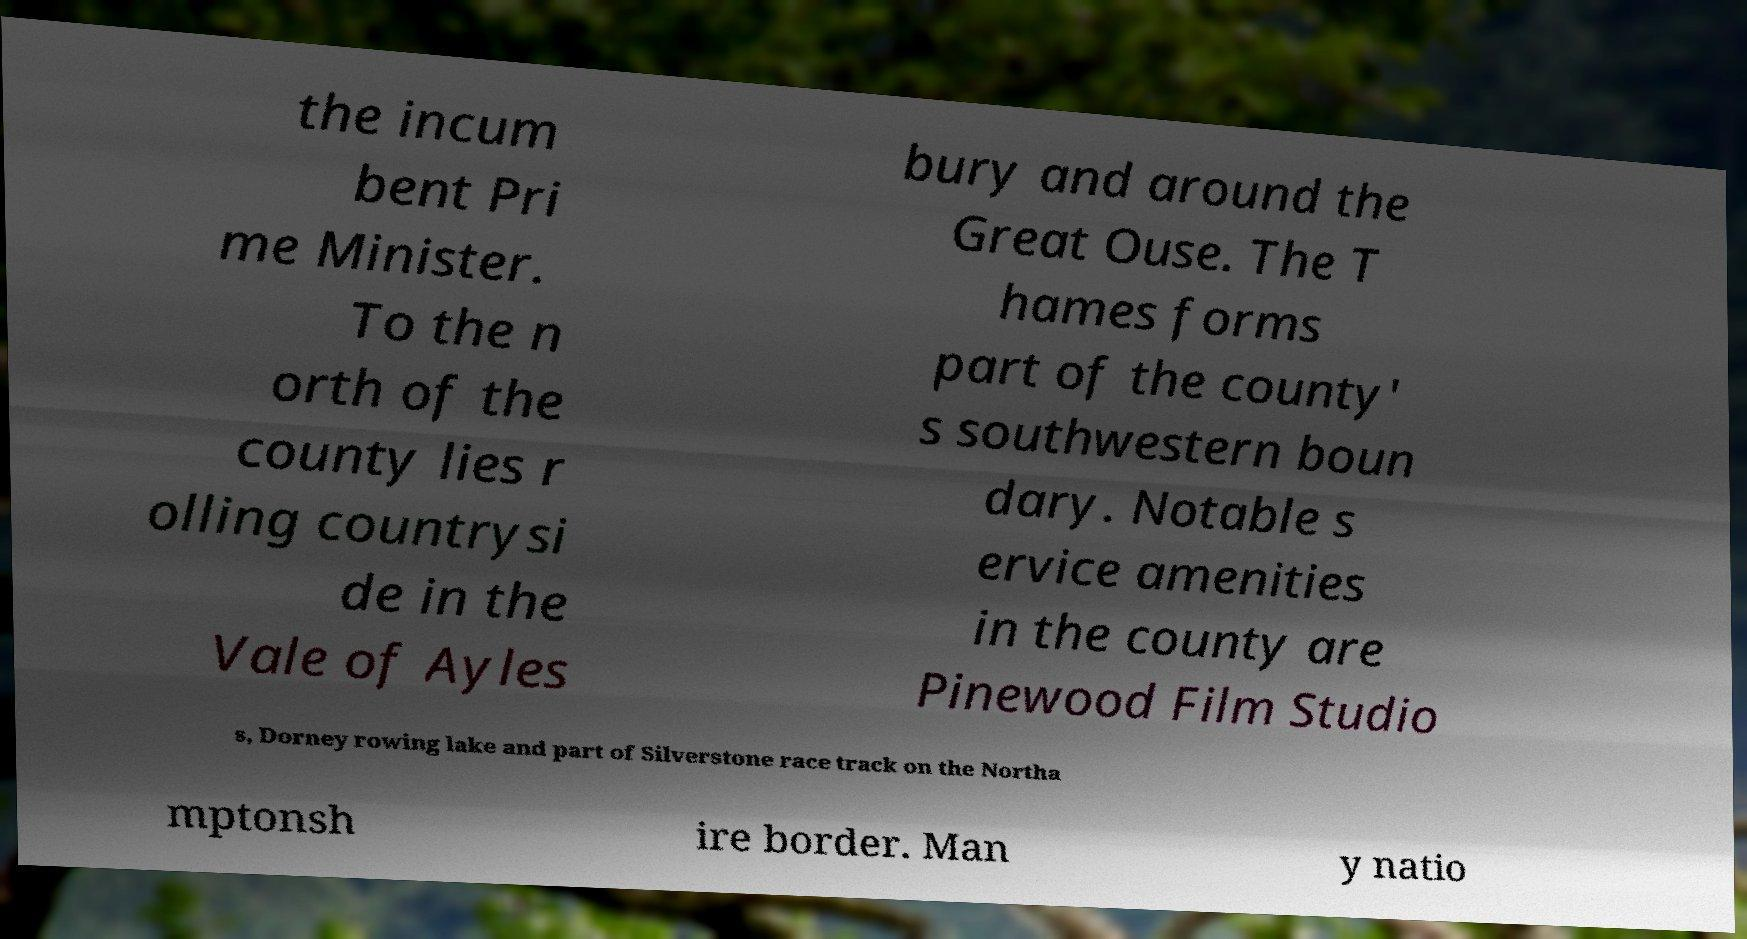For documentation purposes, I need the text within this image transcribed. Could you provide that? the incum bent Pri me Minister. To the n orth of the county lies r olling countrysi de in the Vale of Ayles bury and around the Great Ouse. The T hames forms part of the county' s southwestern boun dary. Notable s ervice amenities in the county are Pinewood Film Studio s, Dorney rowing lake and part of Silverstone race track on the Northa mptonsh ire border. Man y natio 